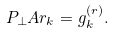<formula> <loc_0><loc_0><loc_500><loc_500>P _ { \perp } A r _ { k } = g _ { k } ^ { ( r ) } .</formula> 